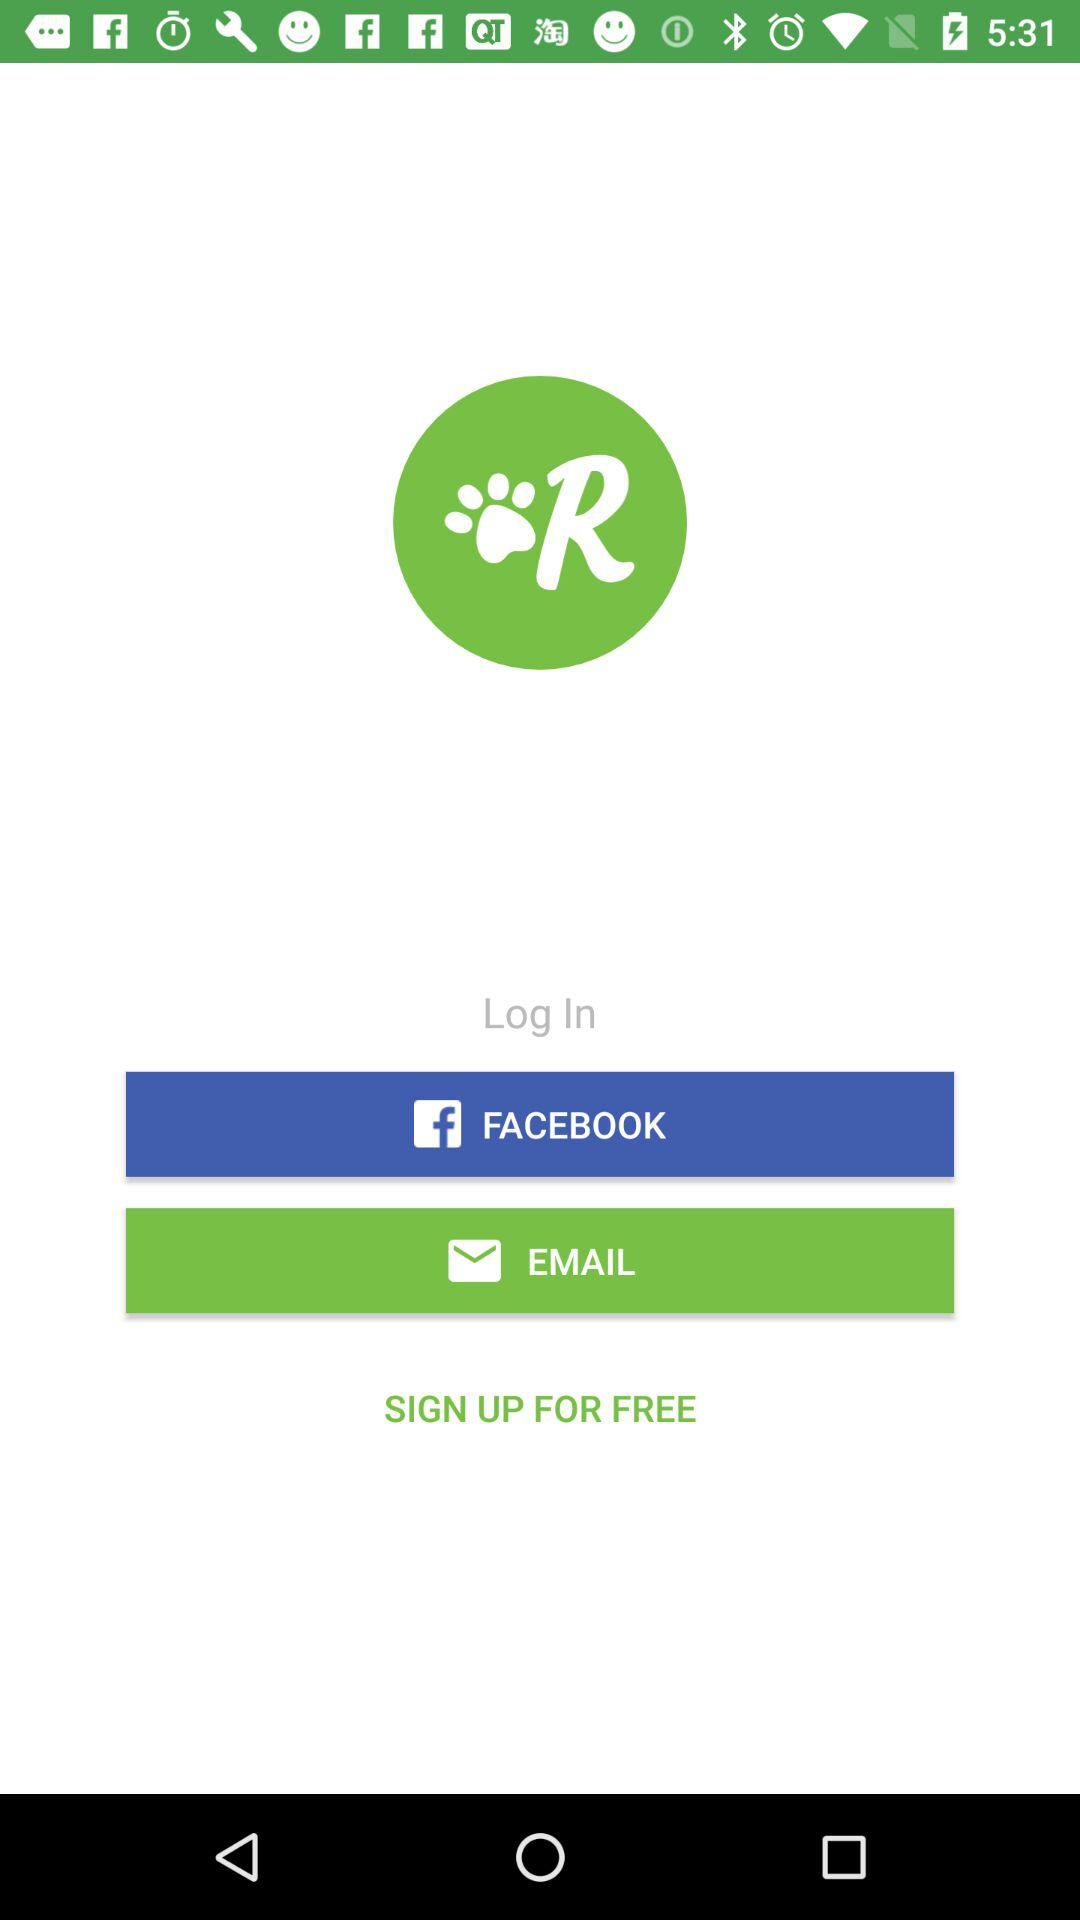What are the log in options? The log in options are "FACEBOOK" and "EMAIL". 